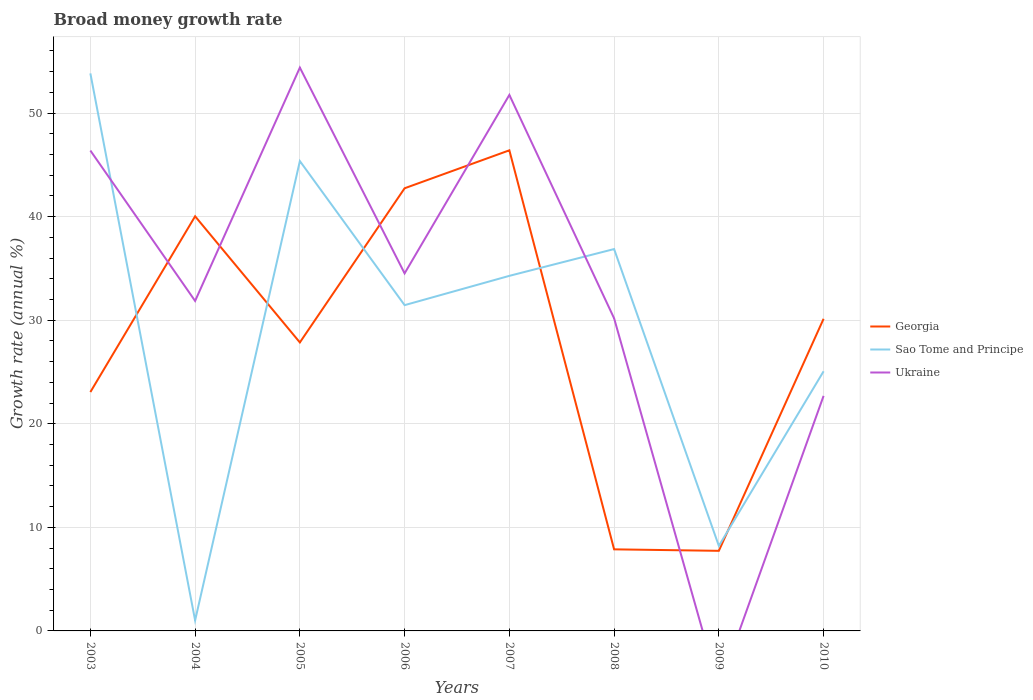Does the line corresponding to Sao Tome and Principe intersect with the line corresponding to Ukraine?
Keep it short and to the point. Yes. Across all years, what is the maximum growth rate in Sao Tome and Principe?
Keep it short and to the point. 1.02. What is the total growth rate in Ukraine in the graph?
Your answer should be compact. 16.2. What is the difference between the highest and the second highest growth rate in Sao Tome and Principe?
Your answer should be compact. 52.81. How many years are there in the graph?
Make the answer very short. 8. Are the values on the major ticks of Y-axis written in scientific E-notation?
Give a very brief answer. No. Does the graph contain grids?
Make the answer very short. Yes. Where does the legend appear in the graph?
Provide a short and direct response. Center right. How are the legend labels stacked?
Give a very brief answer. Vertical. What is the title of the graph?
Give a very brief answer. Broad money growth rate. Does "Grenada" appear as one of the legend labels in the graph?
Your answer should be very brief. No. What is the label or title of the X-axis?
Keep it short and to the point. Years. What is the label or title of the Y-axis?
Your response must be concise. Growth rate (annual %). What is the Growth rate (annual %) in Georgia in 2003?
Offer a very short reply. 23.06. What is the Growth rate (annual %) of Sao Tome and Principe in 2003?
Ensure brevity in your answer.  53.83. What is the Growth rate (annual %) in Ukraine in 2003?
Your answer should be very brief. 46.38. What is the Growth rate (annual %) of Georgia in 2004?
Your answer should be very brief. 40.03. What is the Growth rate (annual %) in Sao Tome and Principe in 2004?
Keep it short and to the point. 1.02. What is the Growth rate (annual %) of Ukraine in 2004?
Keep it short and to the point. 31.86. What is the Growth rate (annual %) of Georgia in 2005?
Make the answer very short. 27.85. What is the Growth rate (annual %) of Sao Tome and Principe in 2005?
Keep it short and to the point. 45.36. What is the Growth rate (annual %) in Ukraine in 2005?
Offer a very short reply. 54.39. What is the Growth rate (annual %) of Georgia in 2006?
Ensure brevity in your answer.  42.74. What is the Growth rate (annual %) of Sao Tome and Principe in 2006?
Your answer should be compact. 31.45. What is the Growth rate (annual %) in Ukraine in 2006?
Your answer should be compact. 34.52. What is the Growth rate (annual %) in Georgia in 2007?
Give a very brief answer. 46.4. What is the Growth rate (annual %) in Sao Tome and Principe in 2007?
Keep it short and to the point. 34.28. What is the Growth rate (annual %) of Ukraine in 2007?
Offer a very short reply. 51.75. What is the Growth rate (annual %) of Georgia in 2008?
Provide a short and direct response. 7.88. What is the Growth rate (annual %) of Sao Tome and Principe in 2008?
Your answer should be compact. 36.87. What is the Growth rate (annual %) of Ukraine in 2008?
Your answer should be very brief. 30.18. What is the Growth rate (annual %) in Georgia in 2009?
Offer a very short reply. 7.73. What is the Growth rate (annual %) of Sao Tome and Principe in 2009?
Make the answer very short. 8.21. What is the Growth rate (annual %) of Ukraine in 2009?
Offer a terse response. 0. What is the Growth rate (annual %) in Georgia in 2010?
Provide a succinct answer. 30.13. What is the Growth rate (annual %) of Sao Tome and Principe in 2010?
Provide a succinct answer. 25.06. What is the Growth rate (annual %) of Ukraine in 2010?
Ensure brevity in your answer.  22.69. Across all years, what is the maximum Growth rate (annual %) in Georgia?
Make the answer very short. 46.4. Across all years, what is the maximum Growth rate (annual %) in Sao Tome and Principe?
Keep it short and to the point. 53.83. Across all years, what is the maximum Growth rate (annual %) of Ukraine?
Offer a very short reply. 54.39. Across all years, what is the minimum Growth rate (annual %) of Georgia?
Your response must be concise. 7.73. Across all years, what is the minimum Growth rate (annual %) of Sao Tome and Principe?
Keep it short and to the point. 1.02. What is the total Growth rate (annual %) in Georgia in the graph?
Provide a short and direct response. 225.82. What is the total Growth rate (annual %) in Sao Tome and Principe in the graph?
Offer a terse response. 236.08. What is the total Growth rate (annual %) of Ukraine in the graph?
Provide a short and direct response. 271.76. What is the difference between the Growth rate (annual %) of Georgia in 2003 and that in 2004?
Your response must be concise. -16.97. What is the difference between the Growth rate (annual %) in Sao Tome and Principe in 2003 and that in 2004?
Provide a short and direct response. 52.81. What is the difference between the Growth rate (annual %) in Ukraine in 2003 and that in 2004?
Make the answer very short. 14.52. What is the difference between the Growth rate (annual %) in Georgia in 2003 and that in 2005?
Keep it short and to the point. -4.79. What is the difference between the Growth rate (annual %) of Sao Tome and Principe in 2003 and that in 2005?
Keep it short and to the point. 8.46. What is the difference between the Growth rate (annual %) in Ukraine in 2003 and that in 2005?
Your answer should be very brief. -8.01. What is the difference between the Growth rate (annual %) of Georgia in 2003 and that in 2006?
Provide a succinct answer. -19.67. What is the difference between the Growth rate (annual %) of Sao Tome and Principe in 2003 and that in 2006?
Provide a succinct answer. 22.37. What is the difference between the Growth rate (annual %) of Ukraine in 2003 and that in 2006?
Your answer should be compact. 11.86. What is the difference between the Growth rate (annual %) of Georgia in 2003 and that in 2007?
Ensure brevity in your answer.  -23.34. What is the difference between the Growth rate (annual %) of Sao Tome and Principe in 2003 and that in 2007?
Keep it short and to the point. 19.55. What is the difference between the Growth rate (annual %) of Ukraine in 2003 and that in 2007?
Your answer should be compact. -5.37. What is the difference between the Growth rate (annual %) of Georgia in 2003 and that in 2008?
Provide a succinct answer. 15.19. What is the difference between the Growth rate (annual %) of Sao Tome and Principe in 2003 and that in 2008?
Ensure brevity in your answer.  16.96. What is the difference between the Growth rate (annual %) of Ukraine in 2003 and that in 2008?
Your response must be concise. 16.2. What is the difference between the Growth rate (annual %) of Georgia in 2003 and that in 2009?
Offer a very short reply. 15.33. What is the difference between the Growth rate (annual %) in Sao Tome and Principe in 2003 and that in 2009?
Ensure brevity in your answer.  45.62. What is the difference between the Growth rate (annual %) of Georgia in 2003 and that in 2010?
Provide a succinct answer. -7.07. What is the difference between the Growth rate (annual %) of Sao Tome and Principe in 2003 and that in 2010?
Keep it short and to the point. 28.76. What is the difference between the Growth rate (annual %) of Ukraine in 2003 and that in 2010?
Provide a short and direct response. 23.69. What is the difference between the Growth rate (annual %) in Georgia in 2004 and that in 2005?
Your answer should be very brief. 12.18. What is the difference between the Growth rate (annual %) of Sao Tome and Principe in 2004 and that in 2005?
Offer a terse response. -44.34. What is the difference between the Growth rate (annual %) in Ukraine in 2004 and that in 2005?
Your response must be concise. -22.53. What is the difference between the Growth rate (annual %) in Georgia in 2004 and that in 2006?
Make the answer very short. -2.71. What is the difference between the Growth rate (annual %) of Sao Tome and Principe in 2004 and that in 2006?
Provide a short and direct response. -30.43. What is the difference between the Growth rate (annual %) of Ukraine in 2004 and that in 2006?
Your answer should be very brief. -2.66. What is the difference between the Growth rate (annual %) of Georgia in 2004 and that in 2007?
Your response must be concise. -6.37. What is the difference between the Growth rate (annual %) of Sao Tome and Principe in 2004 and that in 2007?
Offer a terse response. -33.26. What is the difference between the Growth rate (annual %) of Ukraine in 2004 and that in 2007?
Your response must be concise. -19.89. What is the difference between the Growth rate (annual %) of Georgia in 2004 and that in 2008?
Ensure brevity in your answer.  32.15. What is the difference between the Growth rate (annual %) in Sao Tome and Principe in 2004 and that in 2008?
Provide a succinct answer. -35.85. What is the difference between the Growth rate (annual %) of Ukraine in 2004 and that in 2008?
Your answer should be compact. 1.67. What is the difference between the Growth rate (annual %) in Georgia in 2004 and that in 2009?
Your response must be concise. 32.3. What is the difference between the Growth rate (annual %) in Sao Tome and Principe in 2004 and that in 2009?
Keep it short and to the point. -7.19. What is the difference between the Growth rate (annual %) of Georgia in 2004 and that in 2010?
Provide a succinct answer. 9.9. What is the difference between the Growth rate (annual %) of Sao Tome and Principe in 2004 and that in 2010?
Your answer should be compact. -24.05. What is the difference between the Growth rate (annual %) of Ukraine in 2004 and that in 2010?
Provide a short and direct response. 9.17. What is the difference between the Growth rate (annual %) of Georgia in 2005 and that in 2006?
Give a very brief answer. -14.88. What is the difference between the Growth rate (annual %) in Sao Tome and Principe in 2005 and that in 2006?
Give a very brief answer. 13.91. What is the difference between the Growth rate (annual %) in Ukraine in 2005 and that in 2006?
Your answer should be compact. 19.87. What is the difference between the Growth rate (annual %) in Georgia in 2005 and that in 2007?
Offer a very short reply. -18.55. What is the difference between the Growth rate (annual %) in Sao Tome and Principe in 2005 and that in 2007?
Give a very brief answer. 11.08. What is the difference between the Growth rate (annual %) in Ukraine in 2005 and that in 2007?
Your answer should be compact. 2.64. What is the difference between the Growth rate (annual %) in Georgia in 2005 and that in 2008?
Ensure brevity in your answer.  19.97. What is the difference between the Growth rate (annual %) of Sao Tome and Principe in 2005 and that in 2008?
Give a very brief answer. 8.49. What is the difference between the Growth rate (annual %) of Ukraine in 2005 and that in 2008?
Your response must be concise. 24.2. What is the difference between the Growth rate (annual %) in Georgia in 2005 and that in 2009?
Ensure brevity in your answer.  20.12. What is the difference between the Growth rate (annual %) in Sao Tome and Principe in 2005 and that in 2009?
Offer a terse response. 37.15. What is the difference between the Growth rate (annual %) in Georgia in 2005 and that in 2010?
Your answer should be compact. -2.28. What is the difference between the Growth rate (annual %) of Sao Tome and Principe in 2005 and that in 2010?
Offer a very short reply. 20.3. What is the difference between the Growth rate (annual %) of Ukraine in 2005 and that in 2010?
Ensure brevity in your answer.  31.69. What is the difference between the Growth rate (annual %) of Georgia in 2006 and that in 2007?
Your answer should be very brief. -3.66. What is the difference between the Growth rate (annual %) in Sao Tome and Principe in 2006 and that in 2007?
Offer a very short reply. -2.83. What is the difference between the Growth rate (annual %) in Ukraine in 2006 and that in 2007?
Provide a short and direct response. -17.23. What is the difference between the Growth rate (annual %) in Georgia in 2006 and that in 2008?
Your answer should be very brief. 34.86. What is the difference between the Growth rate (annual %) of Sao Tome and Principe in 2006 and that in 2008?
Provide a succinct answer. -5.42. What is the difference between the Growth rate (annual %) in Ukraine in 2006 and that in 2008?
Provide a succinct answer. 4.34. What is the difference between the Growth rate (annual %) of Georgia in 2006 and that in 2009?
Offer a terse response. 35. What is the difference between the Growth rate (annual %) in Sao Tome and Principe in 2006 and that in 2009?
Make the answer very short. 23.24. What is the difference between the Growth rate (annual %) in Georgia in 2006 and that in 2010?
Offer a very short reply. 12.6. What is the difference between the Growth rate (annual %) of Sao Tome and Principe in 2006 and that in 2010?
Offer a very short reply. 6.39. What is the difference between the Growth rate (annual %) of Ukraine in 2006 and that in 2010?
Provide a succinct answer. 11.83. What is the difference between the Growth rate (annual %) in Georgia in 2007 and that in 2008?
Your answer should be compact. 38.52. What is the difference between the Growth rate (annual %) of Sao Tome and Principe in 2007 and that in 2008?
Provide a succinct answer. -2.59. What is the difference between the Growth rate (annual %) in Ukraine in 2007 and that in 2008?
Offer a terse response. 21.56. What is the difference between the Growth rate (annual %) of Georgia in 2007 and that in 2009?
Your response must be concise. 38.67. What is the difference between the Growth rate (annual %) in Sao Tome and Principe in 2007 and that in 2009?
Your answer should be compact. 26.07. What is the difference between the Growth rate (annual %) in Georgia in 2007 and that in 2010?
Keep it short and to the point. 16.27. What is the difference between the Growth rate (annual %) of Sao Tome and Principe in 2007 and that in 2010?
Your answer should be compact. 9.22. What is the difference between the Growth rate (annual %) of Ukraine in 2007 and that in 2010?
Provide a short and direct response. 29.06. What is the difference between the Growth rate (annual %) in Georgia in 2008 and that in 2009?
Offer a terse response. 0.14. What is the difference between the Growth rate (annual %) of Sao Tome and Principe in 2008 and that in 2009?
Your response must be concise. 28.66. What is the difference between the Growth rate (annual %) of Georgia in 2008 and that in 2010?
Ensure brevity in your answer.  -22.26. What is the difference between the Growth rate (annual %) of Sao Tome and Principe in 2008 and that in 2010?
Keep it short and to the point. 11.8. What is the difference between the Growth rate (annual %) in Ukraine in 2008 and that in 2010?
Your answer should be compact. 7.49. What is the difference between the Growth rate (annual %) of Georgia in 2009 and that in 2010?
Give a very brief answer. -22.4. What is the difference between the Growth rate (annual %) of Sao Tome and Principe in 2009 and that in 2010?
Ensure brevity in your answer.  -16.86. What is the difference between the Growth rate (annual %) in Georgia in 2003 and the Growth rate (annual %) in Sao Tome and Principe in 2004?
Your answer should be very brief. 22.04. What is the difference between the Growth rate (annual %) in Georgia in 2003 and the Growth rate (annual %) in Ukraine in 2004?
Offer a terse response. -8.8. What is the difference between the Growth rate (annual %) in Sao Tome and Principe in 2003 and the Growth rate (annual %) in Ukraine in 2004?
Provide a short and direct response. 21.97. What is the difference between the Growth rate (annual %) of Georgia in 2003 and the Growth rate (annual %) of Sao Tome and Principe in 2005?
Your answer should be compact. -22.3. What is the difference between the Growth rate (annual %) in Georgia in 2003 and the Growth rate (annual %) in Ukraine in 2005?
Ensure brevity in your answer.  -31.32. What is the difference between the Growth rate (annual %) of Sao Tome and Principe in 2003 and the Growth rate (annual %) of Ukraine in 2005?
Give a very brief answer. -0.56. What is the difference between the Growth rate (annual %) of Georgia in 2003 and the Growth rate (annual %) of Sao Tome and Principe in 2006?
Provide a succinct answer. -8.39. What is the difference between the Growth rate (annual %) in Georgia in 2003 and the Growth rate (annual %) in Ukraine in 2006?
Offer a very short reply. -11.46. What is the difference between the Growth rate (annual %) in Sao Tome and Principe in 2003 and the Growth rate (annual %) in Ukraine in 2006?
Provide a short and direct response. 19.31. What is the difference between the Growth rate (annual %) in Georgia in 2003 and the Growth rate (annual %) in Sao Tome and Principe in 2007?
Provide a succinct answer. -11.22. What is the difference between the Growth rate (annual %) of Georgia in 2003 and the Growth rate (annual %) of Ukraine in 2007?
Make the answer very short. -28.69. What is the difference between the Growth rate (annual %) in Sao Tome and Principe in 2003 and the Growth rate (annual %) in Ukraine in 2007?
Offer a very short reply. 2.08. What is the difference between the Growth rate (annual %) in Georgia in 2003 and the Growth rate (annual %) in Sao Tome and Principe in 2008?
Give a very brief answer. -13.81. What is the difference between the Growth rate (annual %) in Georgia in 2003 and the Growth rate (annual %) in Ukraine in 2008?
Provide a short and direct response. -7.12. What is the difference between the Growth rate (annual %) of Sao Tome and Principe in 2003 and the Growth rate (annual %) of Ukraine in 2008?
Offer a very short reply. 23.64. What is the difference between the Growth rate (annual %) of Georgia in 2003 and the Growth rate (annual %) of Sao Tome and Principe in 2009?
Your answer should be compact. 14.85. What is the difference between the Growth rate (annual %) in Georgia in 2003 and the Growth rate (annual %) in Sao Tome and Principe in 2010?
Your answer should be very brief. -2. What is the difference between the Growth rate (annual %) in Georgia in 2003 and the Growth rate (annual %) in Ukraine in 2010?
Provide a succinct answer. 0.37. What is the difference between the Growth rate (annual %) of Sao Tome and Principe in 2003 and the Growth rate (annual %) of Ukraine in 2010?
Provide a succinct answer. 31.13. What is the difference between the Growth rate (annual %) in Georgia in 2004 and the Growth rate (annual %) in Sao Tome and Principe in 2005?
Your answer should be very brief. -5.33. What is the difference between the Growth rate (annual %) in Georgia in 2004 and the Growth rate (annual %) in Ukraine in 2005?
Your response must be concise. -14.36. What is the difference between the Growth rate (annual %) of Sao Tome and Principe in 2004 and the Growth rate (annual %) of Ukraine in 2005?
Ensure brevity in your answer.  -53.37. What is the difference between the Growth rate (annual %) in Georgia in 2004 and the Growth rate (annual %) in Sao Tome and Principe in 2006?
Ensure brevity in your answer.  8.58. What is the difference between the Growth rate (annual %) of Georgia in 2004 and the Growth rate (annual %) of Ukraine in 2006?
Provide a succinct answer. 5.51. What is the difference between the Growth rate (annual %) of Sao Tome and Principe in 2004 and the Growth rate (annual %) of Ukraine in 2006?
Your answer should be compact. -33.5. What is the difference between the Growth rate (annual %) of Georgia in 2004 and the Growth rate (annual %) of Sao Tome and Principe in 2007?
Ensure brevity in your answer.  5.75. What is the difference between the Growth rate (annual %) of Georgia in 2004 and the Growth rate (annual %) of Ukraine in 2007?
Provide a succinct answer. -11.72. What is the difference between the Growth rate (annual %) in Sao Tome and Principe in 2004 and the Growth rate (annual %) in Ukraine in 2007?
Give a very brief answer. -50.73. What is the difference between the Growth rate (annual %) in Georgia in 2004 and the Growth rate (annual %) in Sao Tome and Principe in 2008?
Provide a succinct answer. 3.16. What is the difference between the Growth rate (annual %) of Georgia in 2004 and the Growth rate (annual %) of Ukraine in 2008?
Keep it short and to the point. 9.85. What is the difference between the Growth rate (annual %) in Sao Tome and Principe in 2004 and the Growth rate (annual %) in Ukraine in 2008?
Your answer should be compact. -29.16. What is the difference between the Growth rate (annual %) in Georgia in 2004 and the Growth rate (annual %) in Sao Tome and Principe in 2009?
Ensure brevity in your answer.  31.82. What is the difference between the Growth rate (annual %) of Georgia in 2004 and the Growth rate (annual %) of Sao Tome and Principe in 2010?
Offer a terse response. 14.97. What is the difference between the Growth rate (annual %) of Georgia in 2004 and the Growth rate (annual %) of Ukraine in 2010?
Ensure brevity in your answer.  17.34. What is the difference between the Growth rate (annual %) of Sao Tome and Principe in 2004 and the Growth rate (annual %) of Ukraine in 2010?
Offer a terse response. -21.67. What is the difference between the Growth rate (annual %) in Georgia in 2005 and the Growth rate (annual %) in Ukraine in 2006?
Provide a succinct answer. -6.67. What is the difference between the Growth rate (annual %) of Sao Tome and Principe in 2005 and the Growth rate (annual %) of Ukraine in 2006?
Your response must be concise. 10.84. What is the difference between the Growth rate (annual %) of Georgia in 2005 and the Growth rate (annual %) of Sao Tome and Principe in 2007?
Your response must be concise. -6.43. What is the difference between the Growth rate (annual %) of Georgia in 2005 and the Growth rate (annual %) of Ukraine in 2007?
Provide a succinct answer. -23.9. What is the difference between the Growth rate (annual %) in Sao Tome and Principe in 2005 and the Growth rate (annual %) in Ukraine in 2007?
Provide a short and direct response. -6.39. What is the difference between the Growth rate (annual %) in Georgia in 2005 and the Growth rate (annual %) in Sao Tome and Principe in 2008?
Give a very brief answer. -9.02. What is the difference between the Growth rate (annual %) of Georgia in 2005 and the Growth rate (annual %) of Ukraine in 2008?
Make the answer very short. -2.33. What is the difference between the Growth rate (annual %) of Sao Tome and Principe in 2005 and the Growth rate (annual %) of Ukraine in 2008?
Give a very brief answer. 15.18. What is the difference between the Growth rate (annual %) in Georgia in 2005 and the Growth rate (annual %) in Sao Tome and Principe in 2009?
Offer a very short reply. 19.64. What is the difference between the Growth rate (annual %) of Georgia in 2005 and the Growth rate (annual %) of Sao Tome and Principe in 2010?
Ensure brevity in your answer.  2.79. What is the difference between the Growth rate (annual %) in Georgia in 2005 and the Growth rate (annual %) in Ukraine in 2010?
Offer a very short reply. 5.16. What is the difference between the Growth rate (annual %) in Sao Tome and Principe in 2005 and the Growth rate (annual %) in Ukraine in 2010?
Offer a terse response. 22.67. What is the difference between the Growth rate (annual %) in Georgia in 2006 and the Growth rate (annual %) in Sao Tome and Principe in 2007?
Your response must be concise. 8.46. What is the difference between the Growth rate (annual %) of Georgia in 2006 and the Growth rate (annual %) of Ukraine in 2007?
Your answer should be compact. -9.01. What is the difference between the Growth rate (annual %) in Sao Tome and Principe in 2006 and the Growth rate (annual %) in Ukraine in 2007?
Your response must be concise. -20.3. What is the difference between the Growth rate (annual %) in Georgia in 2006 and the Growth rate (annual %) in Sao Tome and Principe in 2008?
Your answer should be very brief. 5.87. What is the difference between the Growth rate (annual %) of Georgia in 2006 and the Growth rate (annual %) of Ukraine in 2008?
Ensure brevity in your answer.  12.55. What is the difference between the Growth rate (annual %) in Sao Tome and Principe in 2006 and the Growth rate (annual %) in Ukraine in 2008?
Your answer should be compact. 1.27. What is the difference between the Growth rate (annual %) of Georgia in 2006 and the Growth rate (annual %) of Sao Tome and Principe in 2009?
Provide a succinct answer. 34.53. What is the difference between the Growth rate (annual %) in Georgia in 2006 and the Growth rate (annual %) in Sao Tome and Principe in 2010?
Ensure brevity in your answer.  17.67. What is the difference between the Growth rate (annual %) of Georgia in 2006 and the Growth rate (annual %) of Ukraine in 2010?
Offer a terse response. 20.05. What is the difference between the Growth rate (annual %) of Sao Tome and Principe in 2006 and the Growth rate (annual %) of Ukraine in 2010?
Provide a short and direct response. 8.76. What is the difference between the Growth rate (annual %) of Georgia in 2007 and the Growth rate (annual %) of Sao Tome and Principe in 2008?
Offer a terse response. 9.53. What is the difference between the Growth rate (annual %) of Georgia in 2007 and the Growth rate (annual %) of Ukraine in 2008?
Provide a succinct answer. 16.22. What is the difference between the Growth rate (annual %) in Sao Tome and Principe in 2007 and the Growth rate (annual %) in Ukraine in 2008?
Keep it short and to the point. 4.1. What is the difference between the Growth rate (annual %) in Georgia in 2007 and the Growth rate (annual %) in Sao Tome and Principe in 2009?
Your answer should be very brief. 38.19. What is the difference between the Growth rate (annual %) in Georgia in 2007 and the Growth rate (annual %) in Sao Tome and Principe in 2010?
Provide a short and direct response. 21.33. What is the difference between the Growth rate (annual %) of Georgia in 2007 and the Growth rate (annual %) of Ukraine in 2010?
Your response must be concise. 23.71. What is the difference between the Growth rate (annual %) of Sao Tome and Principe in 2007 and the Growth rate (annual %) of Ukraine in 2010?
Provide a short and direct response. 11.59. What is the difference between the Growth rate (annual %) of Georgia in 2008 and the Growth rate (annual %) of Sao Tome and Principe in 2009?
Provide a succinct answer. -0.33. What is the difference between the Growth rate (annual %) of Georgia in 2008 and the Growth rate (annual %) of Sao Tome and Principe in 2010?
Make the answer very short. -17.19. What is the difference between the Growth rate (annual %) of Georgia in 2008 and the Growth rate (annual %) of Ukraine in 2010?
Your answer should be compact. -14.81. What is the difference between the Growth rate (annual %) in Sao Tome and Principe in 2008 and the Growth rate (annual %) in Ukraine in 2010?
Offer a terse response. 14.18. What is the difference between the Growth rate (annual %) of Georgia in 2009 and the Growth rate (annual %) of Sao Tome and Principe in 2010?
Your response must be concise. -17.33. What is the difference between the Growth rate (annual %) of Georgia in 2009 and the Growth rate (annual %) of Ukraine in 2010?
Provide a short and direct response. -14.96. What is the difference between the Growth rate (annual %) in Sao Tome and Principe in 2009 and the Growth rate (annual %) in Ukraine in 2010?
Keep it short and to the point. -14.48. What is the average Growth rate (annual %) of Georgia per year?
Offer a terse response. 28.23. What is the average Growth rate (annual %) of Sao Tome and Principe per year?
Keep it short and to the point. 29.51. What is the average Growth rate (annual %) in Ukraine per year?
Offer a terse response. 33.97. In the year 2003, what is the difference between the Growth rate (annual %) in Georgia and Growth rate (annual %) in Sao Tome and Principe?
Make the answer very short. -30.76. In the year 2003, what is the difference between the Growth rate (annual %) of Georgia and Growth rate (annual %) of Ukraine?
Keep it short and to the point. -23.32. In the year 2003, what is the difference between the Growth rate (annual %) in Sao Tome and Principe and Growth rate (annual %) in Ukraine?
Provide a short and direct response. 7.45. In the year 2004, what is the difference between the Growth rate (annual %) in Georgia and Growth rate (annual %) in Sao Tome and Principe?
Offer a very short reply. 39.01. In the year 2004, what is the difference between the Growth rate (annual %) in Georgia and Growth rate (annual %) in Ukraine?
Offer a very short reply. 8.17. In the year 2004, what is the difference between the Growth rate (annual %) in Sao Tome and Principe and Growth rate (annual %) in Ukraine?
Your response must be concise. -30.84. In the year 2005, what is the difference between the Growth rate (annual %) of Georgia and Growth rate (annual %) of Sao Tome and Principe?
Ensure brevity in your answer.  -17.51. In the year 2005, what is the difference between the Growth rate (annual %) of Georgia and Growth rate (annual %) of Ukraine?
Provide a short and direct response. -26.53. In the year 2005, what is the difference between the Growth rate (annual %) in Sao Tome and Principe and Growth rate (annual %) in Ukraine?
Your answer should be very brief. -9.02. In the year 2006, what is the difference between the Growth rate (annual %) in Georgia and Growth rate (annual %) in Sao Tome and Principe?
Your answer should be compact. 11.29. In the year 2006, what is the difference between the Growth rate (annual %) in Georgia and Growth rate (annual %) in Ukraine?
Your answer should be very brief. 8.22. In the year 2006, what is the difference between the Growth rate (annual %) of Sao Tome and Principe and Growth rate (annual %) of Ukraine?
Offer a very short reply. -3.07. In the year 2007, what is the difference between the Growth rate (annual %) in Georgia and Growth rate (annual %) in Sao Tome and Principe?
Give a very brief answer. 12.12. In the year 2007, what is the difference between the Growth rate (annual %) of Georgia and Growth rate (annual %) of Ukraine?
Ensure brevity in your answer.  -5.35. In the year 2007, what is the difference between the Growth rate (annual %) in Sao Tome and Principe and Growth rate (annual %) in Ukraine?
Provide a succinct answer. -17.47. In the year 2008, what is the difference between the Growth rate (annual %) of Georgia and Growth rate (annual %) of Sao Tome and Principe?
Give a very brief answer. -28.99. In the year 2008, what is the difference between the Growth rate (annual %) of Georgia and Growth rate (annual %) of Ukraine?
Provide a succinct answer. -22.31. In the year 2008, what is the difference between the Growth rate (annual %) in Sao Tome and Principe and Growth rate (annual %) in Ukraine?
Provide a succinct answer. 6.68. In the year 2009, what is the difference between the Growth rate (annual %) in Georgia and Growth rate (annual %) in Sao Tome and Principe?
Your response must be concise. -0.48. In the year 2010, what is the difference between the Growth rate (annual %) in Georgia and Growth rate (annual %) in Sao Tome and Principe?
Offer a terse response. 5.07. In the year 2010, what is the difference between the Growth rate (annual %) of Georgia and Growth rate (annual %) of Ukraine?
Your answer should be very brief. 7.44. In the year 2010, what is the difference between the Growth rate (annual %) of Sao Tome and Principe and Growth rate (annual %) of Ukraine?
Offer a very short reply. 2.37. What is the ratio of the Growth rate (annual %) of Georgia in 2003 to that in 2004?
Your response must be concise. 0.58. What is the ratio of the Growth rate (annual %) of Sao Tome and Principe in 2003 to that in 2004?
Ensure brevity in your answer.  52.86. What is the ratio of the Growth rate (annual %) in Ukraine in 2003 to that in 2004?
Your answer should be compact. 1.46. What is the ratio of the Growth rate (annual %) of Georgia in 2003 to that in 2005?
Make the answer very short. 0.83. What is the ratio of the Growth rate (annual %) in Sao Tome and Principe in 2003 to that in 2005?
Your answer should be compact. 1.19. What is the ratio of the Growth rate (annual %) in Ukraine in 2003 to that in 2005?
Your answer should be very brief. 0.85. What is the ratio of the Growth rate (annual %) of Georgia in 2003 to that in 2006?
Your answer should be very brief. 0.54. What is the ratio of the Growth rate (annual %) of Sao Tome and Principe in 2003 to that in 2006?
Provide a succinct answer. 1.71. What is the ratio of the Growth rate (annual %) in Ukraine in 2003 to that in 2006?
Offer a terse response. 1.34. What is the ratio of the Growth rate (annual %) in Georgia in 2003 to that in 2007?
Provide a short and direct response. 0.5. What is the ratio of the Growth rate (annual %) in Sao Tome and Principe in 2003 to that in 2007?
Make the answer very short. 1.57. What is the ratio of the Growth rate (annual %) of Ukraine in 2003 to that in 2007?
Provide a succinct answer. 0.9. What is the ratio of the Growth rate (annual %) of Georgia in 2003 to that in 2008?
Your answer should be compact. 2.93. What is the ratio of the Growth rate (annual %) in Sao Tome and Principe in 2003 to that in 2008?
Give a very brief answer. 1.46. What is the ratio of the Growth rate (annual %) in Ukraine in 2003 to that in 2008?
Give a very brief answer. 1.54. What is the ratio of the Growth rate (annual %) in Georgia in 2003 to that in 2009?
Your answer should be compact. 2.98. What is the ratio of the Growth rate (annual %) in Sao Tome and Principe in 2003 to that in 2009?
Keep it short and to the point. 6.56. What is the ratio of the Growth rate (annual %) of Georgia in 2003 to that in 2010?
Your response must be concise. 0.77. What is the ratio of the Growth rate (annual %) of Sao Tome and Principe in 2003 to that in 2010?
Ensure brevity in your answer.  2.15. What is the ratio of the Growth rate (annual %) in Ukraine in 2003 to that in 2010?
Your response must be concise. 2.04. What is the ratio of the Growth rate (annual %) of Georgia in 2004 to that in 2005?
Give a very brief answer. 1.44. What is the ratio of the Growth rate (annual %) of Sao Tome and Principe in 2004 to that in 2005?
Ensure brevity in your answer.  0.02. What is the ratio of the Growth rate (annual %) of Ukraine in 2004 to that in 2005?
Offer a terse response. 0.59. What is the ratio of the Growth rate (annual %) in Georgia in 2004 to that in 2006?
Your answer should be very brief. 0.94. What is the ratio of the Growth rate (annual %) in Sao Tome and Principe in 2004 to that in 2006?
Your response must be concise. 0.03. What is the ratio of the Growth rate (annual %) of Ukraine in 2004 to that in 2006?
Your answer should be compact. 0.92. What is the ratio of the Growth rate (annual %) in Georgia in 2004 to that in 2007?
Offer a terse response. 0.86. What is the ratio of the Growth rate (annual %) in Sao Tome and Principe in 2004 to that in 2007?
Ensure brevity in your answer.  0.03. What is the ratio of the Growth rate (annual %) of Ukraine in 2004 to that in 2007?
Keep it short and to the point. 0.62. What is the ratio of the Growth rate (annual %) in Georgia in 2004 to that in 2008?
Your answer should be very brief. 5.08. What is the ratio of the Growth rate (annual %) of Sao Tome and Principe in 2004 to that in 2008?
Ensure brevity in your answer.  0.03. What is the ratio of the Growth rate (annual %) in Ukraine in 2004 to that in 2008?
Give a very brief answer. 1.06. What is the ratio of the Growth rate (annual %) of Georgia in 2004 to that in 2009?
Your answer should be very brief. 5.18. What is the ratio of the Growth rate (annual %) in Sao Tome and Principe in 2004 to that in 2009?
Provide a short and direct response. 0.12. What is the ratio of the Growth rate (annual %) of Georgia in 2004 to that in 2010?
Offer a terse response. 1.33. What is the ratio of the Growth rate (annual %) of Sao Tome and Principe in 2004 to that in 2010?
Ensure brevity in your answer.  0.04. What is the ratio of the Growth rate (annual %) of Ukraine in 2004 to that in 2010?
Your answer should be compact. 1.4. What is the ratio of the Growth rate (annual %) in Georgia in 2005 to that in 2006?
Make the answer very short. 0.65. What is the ratio of the Growth rate (annual %) of Sao Tome and Principe in 2005 to that in 2006?
Your response must be concise. 1.44. What is the ratio of the Growth rate (annual %) in Ukraine in 2005 to that in 2006?
Offer a terse response. 1.58. What is the ratio of the Growth rate (annual %) of Georgia in 2005 to that in 2007?
Provide a succinct answer. 0.6. What is the ratio of the Growth rate (annual %) of Sao Tome and Principe in 2005 to that in 2007?
Keep it short and to the point. 1.32. What is the ratio of the Growth rate (annual %) in Ukraine in 2005 to that in 2007?
Your answer should be very brief. 1.05. What is the ratio of the Growth rate (annual %) in Georgia in 2005 to that in 2008?
Your answer should be compact. 3.54. What is the ratio of the Growth rate (annual %) in Sao Tome and Principe in 2005 to that in 2008?
Offer a terse response. 1.23. What is the ratio of the Growth rate (annual %) in Ukraine in 2005 to that in 2008?
Provide a short and direct response. 1.8. What is the ratio of the Growth rate (annual %) in Georgia in 2005 to that in 2009?
Keep it short and to the point. 3.6. What is the ratio of the Growth rate (annual %) of Sao Tome and Principe in 2005 to that in 2009?
Your response must be concise. 5.53. What is the ratio of the Growth rate (annual %) in Georgia in 2005 to that in 2010?
Keep it short and to the point. 0.92. What is the ratio of the Growth rate (annual %) in Sao Tome and Principe in 2005 to that in 2010?
Ensure brevity in your answer.  1.81. What is the ratio of the Growth rate (annual %) of Ukraine in 2005 to that in 2010?
Give a very brief answer. 2.4. What is the ratio of the Growth rate (annual %) of Georgia in 2006 to that in 2007?
Provide a short and direct response. 0.92. What is the ratio of the Growth rate (annual %) of Sao Tome and Principe in 2006 to that in 2007?
Your answer should be very brief. 0.92. What is the ratio of the Growth rate (annual %) of Ukraine in 2006 to that in 2007?
Your response must be concise. 0.67. What is the ratio of the Growth rate (annual %) in Georgia in 2006 to that in 2008?
Make the answer very short. 5.43. What is the ratio of the Growth rate (annual %) of Sao Tome and Principe in 2006 to that in 2008?
Give a very brief answer. 0.85. What is the ratio of the Growth rate (annual %) of Ukraine in 2006 to that in 2008?
Your answer should be very brief. 1.14. What is the ratio of the Growth rate (annual %) of Georgia in 2006 to that in 2009?
Keep it short and to the point. 5.53. What is the ratio of the Growth rate (annual %) of Sao Tome and Principe in 2006 to that in 2009?
Make the answer very short. 3.83. What is the ratio of the Growth rate (annual %) in Georgia in 2006 to that in 2010?
Offer a very short reply. 1.42. What is the ratio of the Growth rate (annual %) of Sao Tome and Principe in 2006 to that in 2010?
Provide a short and direct response. 1.25. What is the ratio of the Growth rate (annual %) of Ukraine in 2006 to that in 2010?
Ensure brevity in your answer.  1.52. What is the ratio of the Growth rate (annual %) in Georgia in 2007 to that in 2008?
Offer a terse response. 5.89. What is the ratio of the Growth rate (annual %) in Sao Tome and Principe in 2007 to that in 2008?
Your response must be concise. 0.93. What is the ratio of the Growth rate (annual %) of Ukraine in 2007 to that in 2008?
Provide a succinct answer. 1.71. What is the ratio of the Growth rate (annual %) of Georgia in 2007 to that in 2009?
Your answer should be very brief. 6. What is the ratio of the Growth rate (annual %) of Sao Tome and Principe in 2007 to that in 2009?
Provide a short and direct response. 4.18. What is the ratio of the Growth rate (annual %) in Georgia in 2007 to that in 2010?
Give a very brief answer. 1.54. What is the ratio of the Growth rate (annual %) in Sao Tome and Principe in 2007 to that in 2010?
Give a very brief answer. 1.37. What is the ratio of the Growth rate (annual %) in Ukraine in 2007 to that in 2010?
Provide a succinct answer. 2.28. What is the ratio of the Growth rate (annual %) of Georgia in 2008 to that in 2009?
Offer a very short reply. 1.02. What is the ratio of the Growth rate (annual %) of Sao Tome and Principe in 2008 to that in 2009?
Offer a terse response. 4.49. What is the ratio of the Growth rate (annual %) in Georgia in 2008 to that in 2010?
Your answer should be compact. 0.26. What is the ratio of the Growth rate (annual %) in Sao Tome and Principe in 2008 to that in 2010?
Your response must be concise. 1.47. What is the ratio of the Growth rate (annual %) of Ukraine in 2008 to that in 2010?
Your response must be concise. 1.33. What is the ratio of the Growth rate (annual %) in Georgia in 2009 to that in 2010?
Ensure brevity in your answer.  0.26. What is the ratio of the Growth rate (annual %) of Sao Tome and Principe in 2009 to that in 2010?
Ensure brevity in your answer.  0.33. What is the difference between the highest and the second highest Growth rate (annual %) in Georgia?
Make the answer very short. 3.66. What is the difference between the highest and the second highest Growth rate (annual %) of Sao Tome and Principe?
Make the answer very short. 8.46. What is the difference between the highest and the second highest Growth rate (annual %) in Ukraine?
Offer a terse response. 2.64. What is the difference between the highest and the lowest Growth rate (annual %) in Georgia?
Provide a succinct answer. 38.67. What is the difference between the highest and the lowest Growth rate (annual %) in Sao Tome and Principe?
Make the answer very short. 52.81. What is the difference between the highest and the lowest Growth rate (annual %) of Ukraine?
Ensure brevity in your answer.  54.39. 